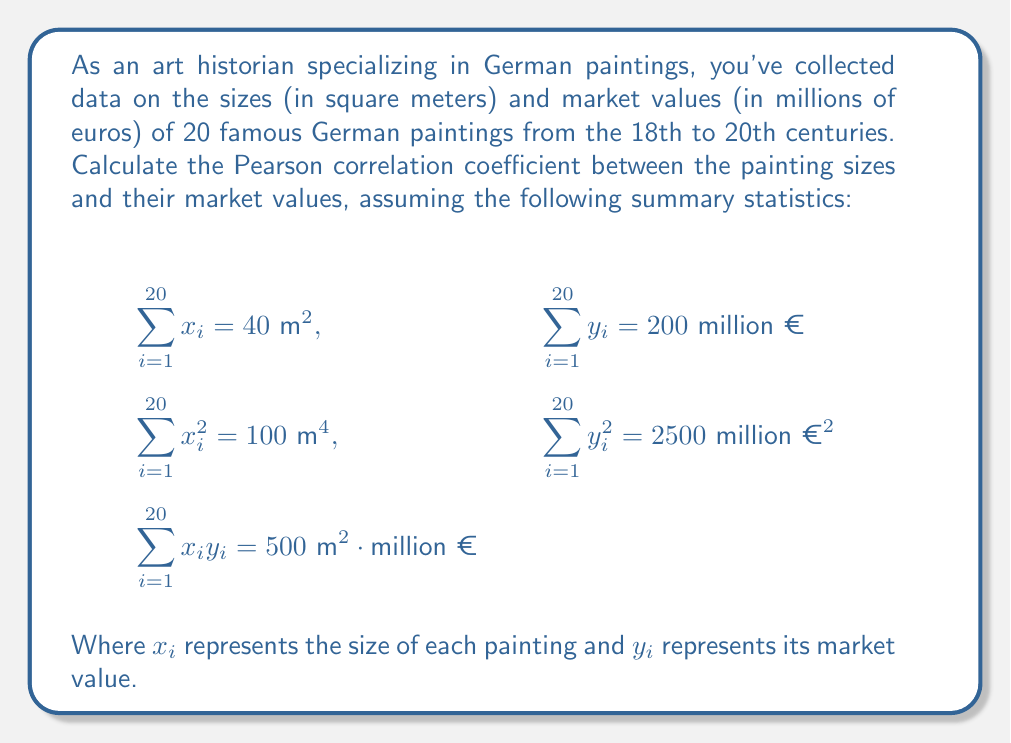Can you answer this question? To calculate the Pearson correlation coefficient, we'll use the formula:

$$r = \frac{n\sum x_iy_i - (\sum x_i)(\sum y_i)}{\sqrt{[n\sum x_i^2 - (\sum x_i)^2][n\sum y_i^2 - (\sum y_i)^2]}}$$

Where $n$ is the number of paintings (20 in this case).

Let's substitute the given values:

1) $n = 20$
2) $\sum x_i = 40$
3) $\sum y_i = 200$
4) $\sum x_i^2 = 100$
5) $\sum y_i^2 = 2500$
6) $\sum x_iy_i = 500$

Now, let's calculate step by step:

1) Numerator: $20(500) - (40)(200) = 10000 - 8000 = 2000$

2) Denominator part 1: $20(100) - (40)^2 = 2000 - 1600 = 400$

3) Denominator part 2: $20(2500) - (200)^2 = 50000 - 40000 = 10000$

4) Full denominator: $\sqrt{(400)(10000)} = \sqrt{4000000} = 2000$

5) Final calculation: $r = \frac{2000}{2000} = 1$

Therefore, the Pearson correlation coefficient is 1, indicating a perfect positive linear correlation between painting sizes and their market values.
Answer: $r = 1$ 